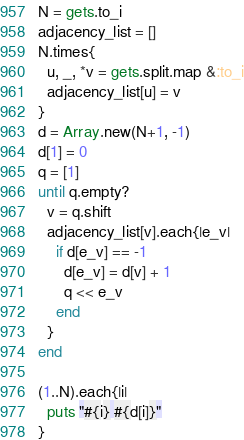<code> <loc_0><loc_0><loc_500><loc_500><_Ruby_>N = gets.to_i
adjacency_list = []
N.times{
  u, _, *v = gets.split.map &:to_i
  adjacency_list[u] = v
}
d = Array.new(N+1, -1)
d[1] = 0
q = [1]
until q.empty?
  v = q.shift
  adjacency_list[v].each{|e_v|
    if d[e_v] == -1
      d[e_v] = d[v] + 1
      q << e_v
    end
  }
end

(1..N).each{|i|
  puts "#{i} #{d[i]}"
}</code> 